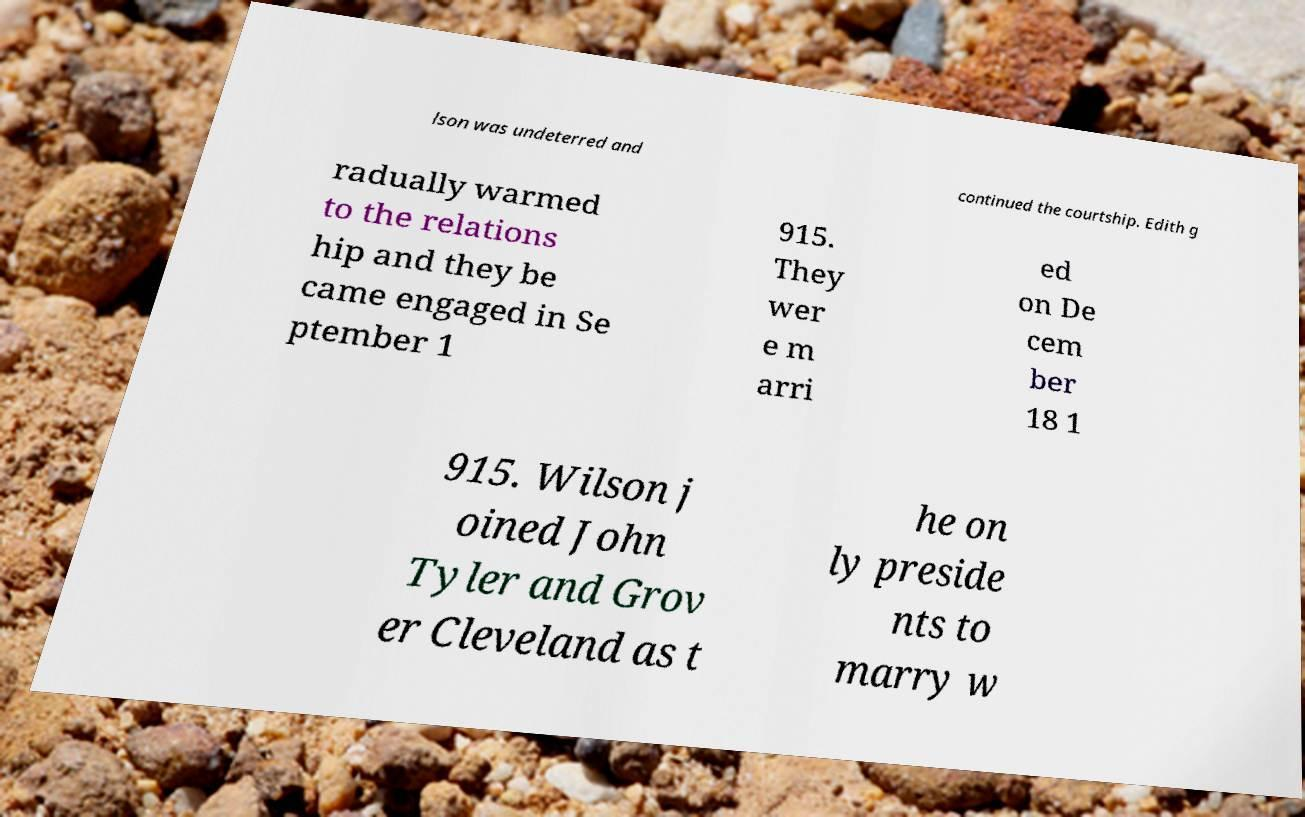What messages or text are displayed in this image? I need them in a readable, typed format. lson was undeterred and continued the courtship. Edith g radually warmed to the relations hip and they be came engaged in Se ptember 1 915. They wer e m arri ed on De cem ber 18 1 915. Wilson j oined John Tyler and Grov er Cleveland as t he on ly preside nts to marry w 